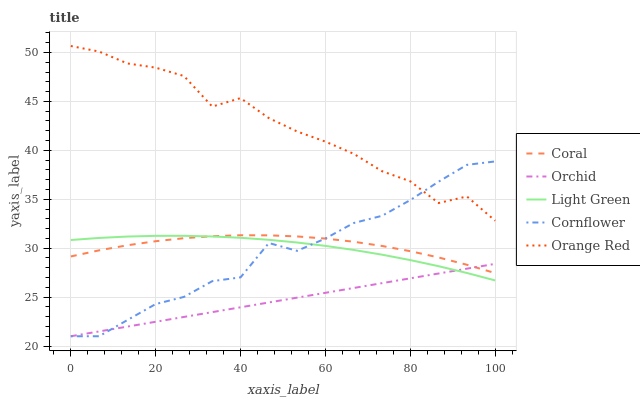Does Coral have the minimum area under the curve?
Answer yes or no. No. Does Coral have the maximum area under the curve?
Answer yes or no. No. Is Coral the smoothest?
Answer yes or no. No. Is Coral the roughest?
Answer yes or no. No. Does Coral have the lowest value?
Answer yes or no. No. Does Coral have the highest value?
Answer yes or no. No. Is Light Green less than Orange Red?
Answer yes or no. Yes. Is Orange Red greater than Orchid?
Answer yes or no. Yes. Does Light Green intersect Orange Red?
Answer yes or no. No. 